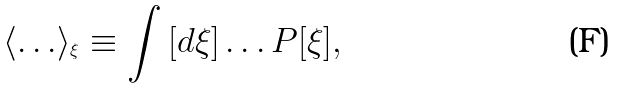<formula> <loc_0><loc_0><loc_500><loc_500>\left \langle { \dots } \right \rangle _ { ^ { \xi } } \equiv \int { [ d \xi ] } \dots P [ \xi ] ,</formula> 